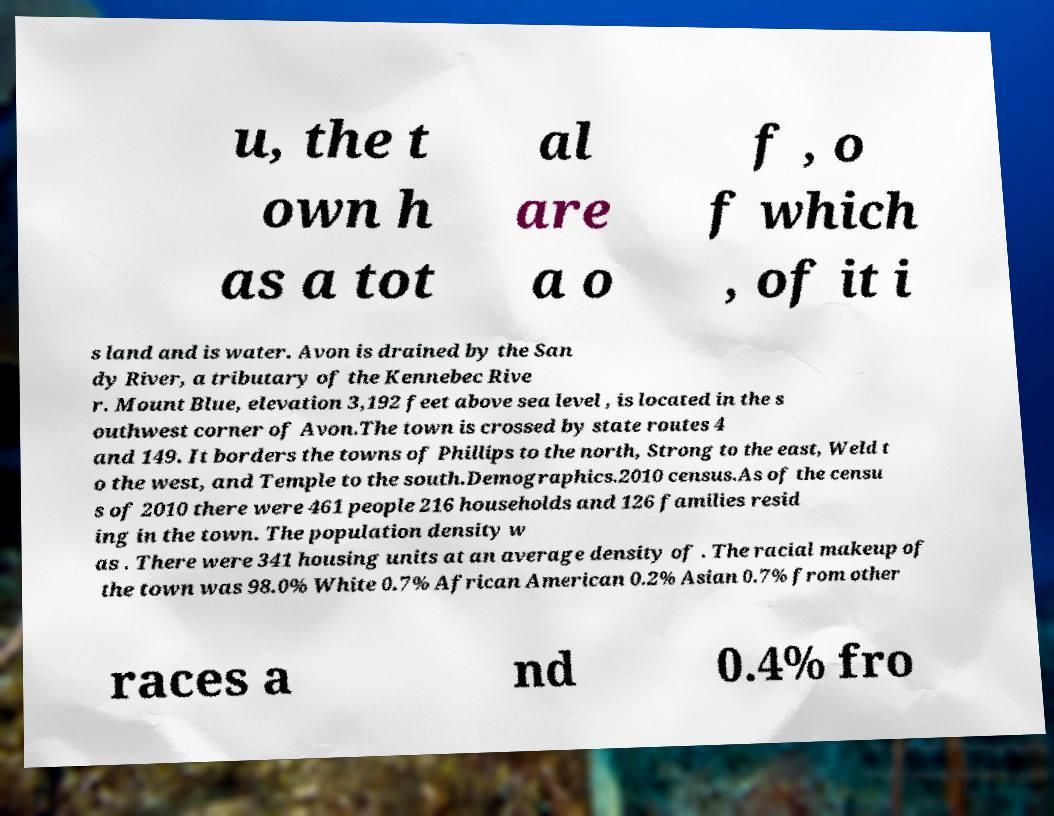Please identify and transcribe the text found in this image. u, the t own h as a tot al are a o f , o f which , of it i s land and is water. Avon is drained by the San dy River, a tributary of the Kennebec Rive r. Mount Blue, elevation 3,192 feet above sea level , is located in the s outhwest corner of Avon.The town is crossed by state routes 4 and 149. It borders the towns of Phillips to the north, Strong to the east, Weld t o the west, and Temple to the south.Demographics.2010 census.As of the censu s of 2010 there were 461 people 216 households and 126 families resid ing in the town. The population density w as . There were 341 housing units at an average density of . The racial makeup of the town was 98.0% White 0.7% African American 0.2% Asian 0.7% from other races a nd 0.4% fro 